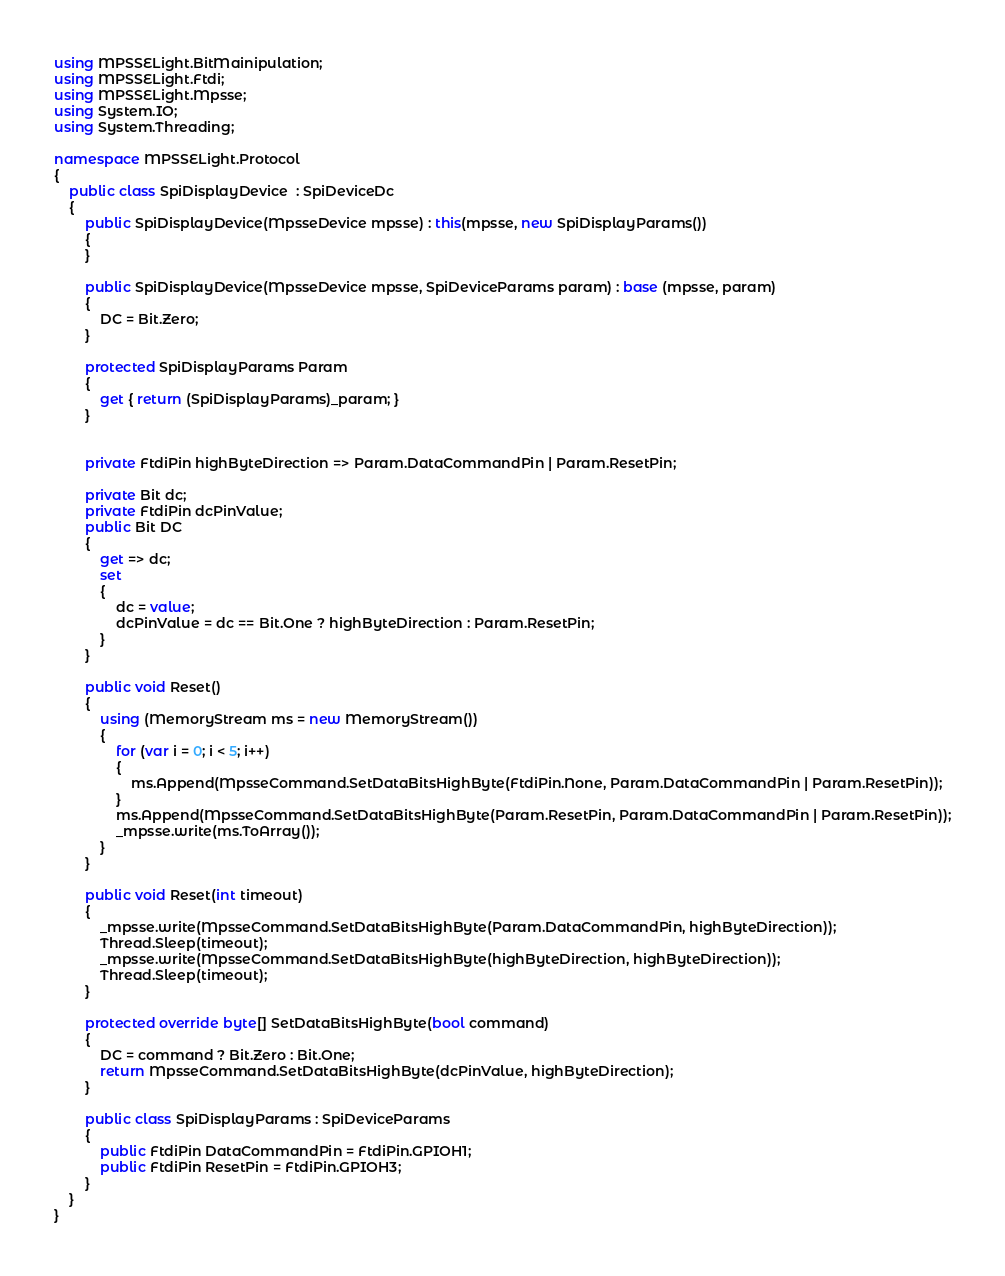<code> <loc_0><loc_0><loc_500><loc_500><_C#_>using MPSSELight.BitMainipulation;
using MPSSELight.Ftdi;
using MPSSELight.Mpsse;
using System.IO;
using System.Threading;

namespace MPSSELight.Protocol
{
    public class SpiDisplayDevice  : SpiDeviceDc
    {
        public SpiDisplayDevice(MpsseDevice mpsse) : this(mpsse, new SpiDisplayParams())
        {
        }

        public SpiDisplayDevice(MpsseDevice mpsse, SpiDeviceParams param) : base (mpsse, param)
        {
            DC = Bit.Zero;
        }

        protected SpiDisplayParams Param
        {
            get { return (SpiDisplayParams)_param; }
        }


        private FtdiPin highByteDirection => Param.DataCommandPin | Param.ResetPin;

        private Bit dc;
        private FtdiPin dcPinValue;
        public Bit DC
        {
            get => dc;
            set
            {
                dc = value;
                dcPinValue = dc == Bit.One ? highByteDirection : Param.ResetPin;
            }
        }

        public void Reset()
        {
            using (MemoryStream ms = new MemoryStream())
            {
                for (var i = 0; i < 5; i++)
                {
                    ms.Append(MpsseCommand.SetDataBitsHighByte(FtdiPin.None, Param.DataCommandPin | Param.ResetPin));
                }
                ms.Append(MpsseCommand.SetDataBitsHighByte(Param.ResetPin, Param.DataCommandPin | Param.ResetPin));
                _mpsse.write(ms.ToArray());
            }
        }

        public void Reset(int timeout)
        {
            _mpsse.write(MpsseCommand.SetDataBitsHighByte(Param.DataCommandPin, highByteDirection));
            Thread.Sleep(timeout);
            _mpsse.write(MpsseCommand.SetDataBitsHighByte(highByteDirection, highByteDirection));
            Thread.Sleep(timeout);
        }

        protected override byte[] SetDataBitsHighByte(bool command)
        {
            DC = command ? Bit.Zero : Bit.One;
            return MpsseCommand.SetDataBitsHighByte(dcPinValue, highByteDirection);
        }

        public class SpiDisplayParams : SpiDeviceParams
        {
            public FtdiPin DataCommandPin = FtdiPin.GPIOH1;
            public FtdiPin ResetPin = FtdiPin.GPIOH3;
        }
    }
}</code> 